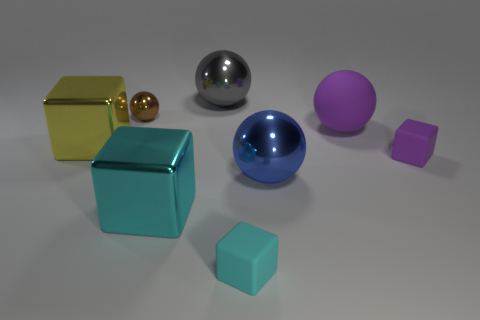Add 1 large cyan matte blocks. How many objects exist? 9 Subtract all cyan matte cubes. How many cubes are left? 3 Subtract 2 spheres. How many spheres are left? 2 Subtract all brown balls. How many balls are left? 3 Subtract all yellow cubes. How many blue spheres are left? 1 Subtract all tiny gray cylinders. Subtract all metallic spheres. How many objects are left? 5 Add 8 big gray objects. How many big gray objects are left? 9 Add 4 big matte objects. How many big matte objects exist? 5 Subtract 1 blue balls. How many objects are left? 7 Subtract all yellow spheres. Subtract all blue cylinders. How many spheres are left? 4 